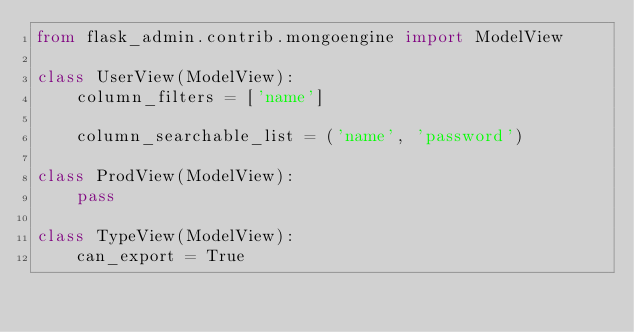<code> <loc_0><loc_0><loc_500><loc_500><_Python_>from flask_admin.contrib.mongoengine import ModelView

class UserView(ModelView):
    column_filters = ['name']

    column_searchable_list = ('name', 'password')

class ProdView(ModelView):
    pass

class TypeView(ModelView):
    can_export = True
</code> 